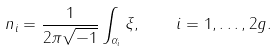Convert formula to latex. <formula><loc_0><loc_0><loc_500><loc_500>n _ { i } = \frac { 1 } { 2 \pi \sqrt { - 1 } } \int _ { \alpha _ { i } } \xi , \quad i = 1 , \dots , 2 g .</formula> 